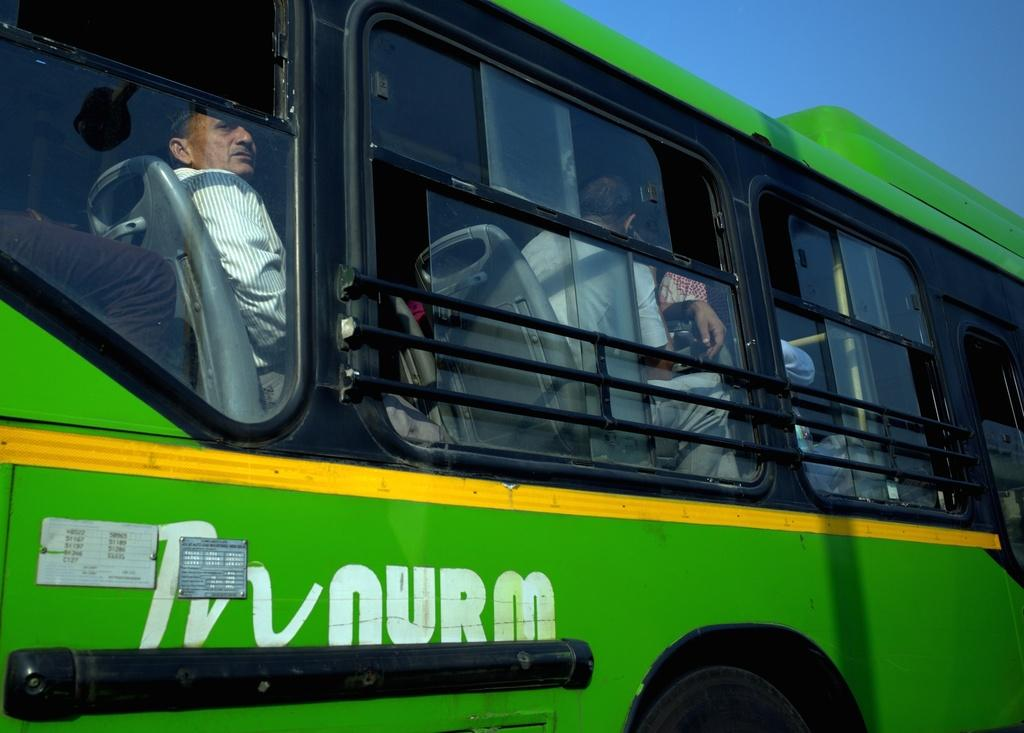What is the main subject of the image? The main subject of the image is a bus. How many people are inside the bus? Many people are sitting inside the bus. What color is the bus? The bus is green in color. What part of the bus can be seen at the bottom of the image? There is a wheel visible at the bottom of the image. What is visible at the top of the image? The sky is visible at the top of the image. What flavor of ice cream is the carpenter eating on the bus in the image? There is no carpenter or ice cream present in the image. What type of noise can be heard coming from the bus in the image? The image is silent, so no noise can be heard. 